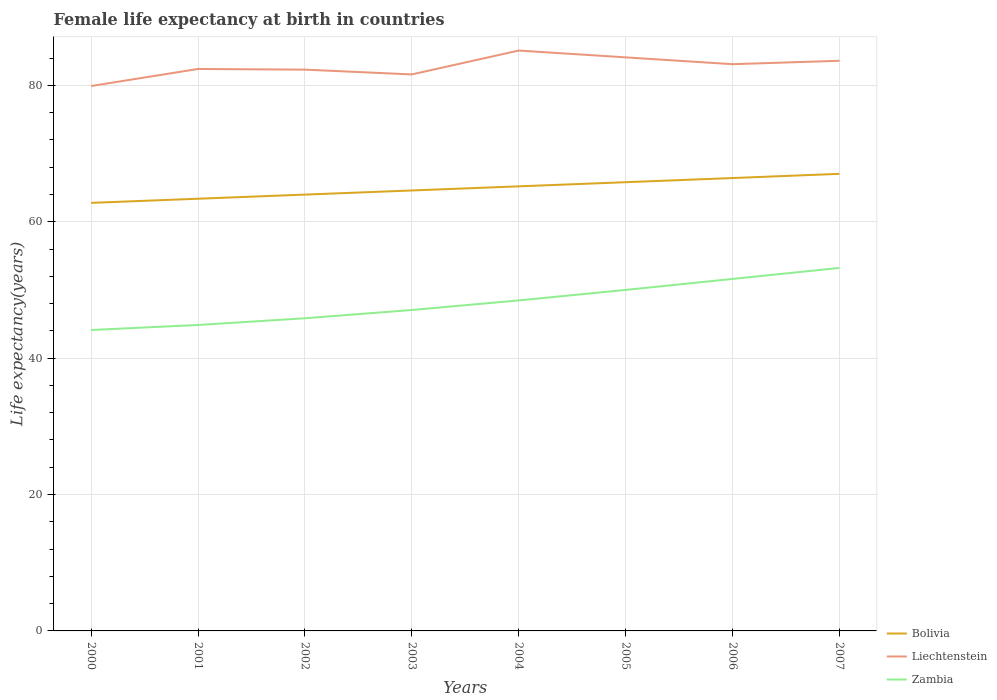How many different coloured lines are there?
Your response must be concise. 3. Across all years, what is the maximum female life expectancy at birth in Bolivia?
Your answer should be very brief. 62.77. What is the total female life expectancy at birth in Zambia in the graph?
Provide a short and direct response. -2.2. What is the difference between the highest and the second highest female life expectancy at birth in Zambia?
Make the answer very short. 9.11. How many lines are there?
Your answer should be compact. 3. Does the graph contain any zero values?
Offer a very short reply. No. Does the graph contain grids?
Provide a short and direct response. Yes. Where does the legend appear in the graph?
Ensure brevity in your answer.  Bottom right. What is the title of the graph?
Provide a short and direct response. Female life expectancy at birth in countries. Does "Yemen, Rep." appear as one of the legend labels in the graph?
Your answer should be very brief. No. What is the label or title of the X-axis?
Make the answer very short. Years. What is the label or title of the Y-axis?
Offer a terse response. Life expectancy(years). What is the Life expectancy(years) of Bolivia in 2000?
Provide a short and direct response. 62.77. What is the Life expectancy(years) of Liechtenstein in 2000?
Offer a very short reply. 79.9. What is the Life expectancy(years) of Zambia in 2000?
Make the answer very short. 44.12. What is the Life expectancy(years) in Bolivia in 2001?
Your answer should be compact. 63.37. What is the Life expectancy(years) in Liechtenstein in 2001?
Your answer should be very brief. 82.4. What is the Life expectancy(years) of Zambia in 2001?
Offer a very short reply. 44.86. What is the Life expectancy(years) in Bolivia in 2002?
Your answer should be compact. 63.98. What is the Life expectancy(years) of Liechtenstein in 2002?
Your response must be concise. 82.3. What is the Life expectancy(years) of Zambia in 2002?
Provide a short and direct response. 45.85. What is the Life expectancy(years) in Bolivia in 2003?
Provide a short and direct response. 64.58. What is the Life expectancy(years) in Liechtenstein in 2003?
Give a very brief answer. 81.6. What is the Life expectancy(years) of Zambia in 2003?
Your answer should be compact. 47.06. What is the Life expectancy(years) of Bolivia in 2004?
Make the answer very short. 65.19. What is the Life expectancy(years) of Liechtenstein in 2004?
Ensure brevity in your answer.  85.1. What is the Life expectancy(years) in Zambia in 2004?
Offer a terse response. 48.46. What is the Life expectancy(years) of Bolivia in 2005?
Your response must be concise. 65.8. What is the Life expectancy(years) of Liechtenstein in 2005?
Give a very brief answer. 84.1. What is the Life expectancy(years) of Zambia in 2005?
Offer a terse response. 50. What is the Life expectancy(years) of Bolivia in 2006?
Offer a terse response. 66.41. What is the Life expectancy(years) of Liechtenstein in 2006?
Provide a short and direct response. 83.1. What is the Life expectancy(years) in Zambia in 2006?
Offer a very short reply. 51.61. What is the Life expectancy(years) of Bolivia in 2007?
Make the answer very short. 67.02. What is the Life expectancy(years) in Liechtenstein in 2007?
Your response must be concise. 83.6. What is the Life expectancy(years) of Zambia in 2007?
Ensure brevity in your answer.  53.23. Across all years, what is the maximum Life expectancy(years) of Bolivia?
Keep it short and to the point. 67.02. Across all years, what is the maximum Life expectancy(years) of Liechtenstein?
Ensure brevity in your answer.  85.1. Across all years, what is the maximum Life expectancy(years) of Zambia?
Keep it short and to the point. 53.23. Across all years, what is the minimum Life expectancy(years) in Bolivia?
Your answer should be very brief. 62.77. Across all years, what is the minimum Life expectancy(years) of Liechtenstein?
Provide a succinct answer. 79.9. Across all years, what is the minimum Life expectancy(years) of Zambia?
Your response must be concise. 44.12. What is the total Life expectancy(years) of Bolivia in the graph?
Ensure brevity in your answer.  519.11. What is the total Life expectancy(years) of Liechtenstein in the graph?
Your response must be concise. 662.1. What is the total Life expectancy(years) of Zambia in the graph?
Your answer should be very brief. 385.19. What is the difference between the Life expectancy(years) of Bolivia in 2000 and that in 2001?
Your answer should be very brief. -0.6. What is the difference between the Life expectancy(years) of Zambia in 2000 and that in 2001?
Offer a very short reply. -0.74. What is the difference between the Life expectancy(years) of Bolivia in 2000 and that in 2002?
Offer a terse response. -1.21. What is the difference between the Life expectancy(years) of Zambia in 2000 and that in 2002?
Keep it short and to the point. -1.73. What is the difference between the Life expectancy(years) in Bolivia in 2000 and that in 2003?
Provide a short and direct response. -1.82. What is the difference between the Life expectancy(years) of Zambia in 2000 and that in 2003?
Your response must be concise. -2.94. What is the difference between the Life expectancy(years) of Bolivia in 2000 and that in 2004?
Give a very brief answer. -2.42. What is the difference between the Life expectancy(years) of Liechtenstein in 2000 and that in 2004?
Your response must be concise. -5.2. What is the difference between the Life expectancy(years) of Zambia in 2000 and that in 2004?
Offer a very short reply. -4.34. What is the difference between the Life expectancy(years) in Bolivia in 2000 and that in 2005?
Make the answer very short. -3.03. What is the difference between the Life expectancy(years) in Liechtenstein in 2000 and that in 2005?
Give a very brief answer. -4.2. What is the difference between the Life expectancy(years) in Zambia in 2000 and that in 2005?
Offer a terse response. -5.88. What is the difference between the Life expectancy(years) of Bolivia in 2000 and that in 2006?
Offer a terse response. -3.64. What is the difference between the Life expectancy(years) of Liechtenstein in 2000 and that in 2006?
Keep it short and to the point. -3.2. What is the difference between the Life expectancy(years) in Zambia in 2000 and that in 2006?
Make the answer very short. -7.49. What is the difference between the Life expectancy(years) of Bolivia in 2000 and that in 2007?
Ensure brevity in your answer.  -4.25. What is the difference between the Life expectancy(years) of Zambia in 2000 and that in 2007?
Offer a terse response. -9.11. What is the difference between the Life expectancy(years) of Bolivia in 2001 and that in 2002?
Provide a succinct answer. -0.61. What is the difference between the Life expectancy(years) in Liechtenstein in 2001 and that in 2002?
Offer a very short reply. 0.1. What is the difference between the Life expectancy(years) in Zambia in 2001 and that in 2002?
Give a very brief answer. -0.98. What is the difference between the Life expectancy(years) of Bolivia in 2001 and that in 2003?
Give a very brief answer. -1.21. What is the difference between the Life expectancy(years) of Liechtenstein in 2001 and that in 2003?
Provide a succinct answer. 0.8. What is the difference between the Life expectancy(years) of Zambia in 2001 and that in 2003?
Your answer should be very brief. -2.2. What is the difference between the Life expectancy(years) of Bolivia in 2001 and that in 2004?
Offer a very short reply. -1.82. What is the difference between the Life expectancy(years) in Liechtenstein in 2001 and that in 2004?
Your answer should be very brief. -2.7. What is the difference between the Life expectancy(years) of Zambia in 2001 and that in 2004?
Ensure brevity in your answer.  -3.6. What is the difference between the Life expectancy(years) in Bolivia in 2001 and that in 2005?
Make the answer very short. -2.42. What is the difference between the Life expectancy(years) of Liechtenstein in 2001 and that in 2005?
Keep it short and to the point. -1.7. What is the difference between the Life expectancy(years) in Zambia in 2001 and that in 2005?
Make the answer very short. -5.14. What is the difference between the Life expectancy(years) in Bolivia in 2001 and that in 2006?
Provide a succinct answer. -3.03. What is the difference between the Life expectancy(years) in Zambia in 2001 and that in 2006?
Your answer should be very brief. -6.75. What is the difference between the Life expectancy(years) in Bolivia in 2001 and that in 2007?
Give a very brief answer. -3.65. What is the difference between the Life expectancy(years) of Liechtenstein in 2001 and that in 2007?
Provide a succinct answer. -1.2. What is the difference between the Life expectancy(years) in Zambia in 2001 and that in 2007?
Provide a short and direct response. -8.37. What is the difference between the Life expectancy(years) in Bolivia in 2002 and that in 2003?
Make the answer very short. -0.61. What is the difference between the Life expectancy(years) of Liechtenstein in 2002 and that in 2003?
Ensure brevity in your answer.  0.7. What is the difference between the Life expectancy(years) of Zambia in 2002 and that in 2003?
Give a very brief answer. -1.21. What is the difference between the Life expectancy(years) of Bolivia in 2002 and that in 2004?
Your answer should be very brief. -1.21. What is the difference between the Life expectancy(years) in Liechtenstein in 2002 and that in 2004?
Keep it short and to the point. -2.8. What is the difference between the Life expectancy(years) of Zambia in 2002 and that in 2004?
Ensure brevity in your answer.  -2.62. What is the difference between the Life expectancy(years) of Bolivia in 2002 and that in 2005?
Offer a terse response. -1.82. What is the difference between the Life expectancy(years) in Liechtenstein in 2002 and that in 2005?
Keep it short and to the point. -1.8. What is the difference between the Life expectancy(years) in Zambia in 2002 and that in 2005?
Your answer should be compact. -4.16. What is the difference between the Life expectancy(years) of Bolivia in 2002 and that in 2006?
Your response must be concise. -2.43. What is the difference between the Life expectancy(years) in Zambia in 2002 and that in 2006?
Keep it short and to the point. -5.77. What is the difference between the Life expectancy(years) in Bolivia in 2002 and that in 2007?
Your response must be concise. -3.04. What is the difference between the Life expectancy(years) in Liechtenstein in 2002 and that in 2007?
Provide a succinct answer. -1.3. What is the difference between the Life expectancy(years) of Zambia in 2002 and that in 2007?
Offer a terse response. -7.38. What is the difference between the Life expectancy(years) in Bolivia in 2003 and that in 2004?
Provide a succinct answer. -0.6. What is the difference between the Life expectancy(years) of Zambia in 2003 and that in 2004?
Make the answer very short. -1.4. What is the difference between the Life expectancy(years) in Bolivia in 2003 and that in 2005?
Offer a terse response. -1.21. What is the difference between the Life expectancy(years) in Liechtenstein in 2003 and that in 2005?
Provide a succinct answer. -2.5. What is the difference between the Life expectancy(years) of Zambia in 2003 and that in 2005?
Your answer should be very brief. -2.94. What is the difference between the Life expectancy(years) in Bolivia in 2003 and that in 2006?
Your answer should be very brief. -1.82. What is the difference between the Life expectancy(years) in Liechtenstein in 2003 and that in 2006?
Make the answer very short. -1.5. What is the difference between the Life expectancy(years) in Zambia in 2003 and that in 2006?
Give a very brief answer. -4.55. What is the difference between the Life expectancy(years) of Bolivia in 2003 and that in 2007?
Provide a succinct answer. -2.44. What is the difference between the Life expectancy(years) of Liechtenstein in 2003 and that in 2007?
Offer a very short reply. -2. What is the difference between the Life expectancy(years) in Zambia in 2003 and that in 2007?
Make the answer very short. -6.17. What is the difference between the Life expectancy(years) in Bolivia in 2004 and that in 2005?
Give a very brief answer. -0.61. What is the difference between the Life expectancy(years) in Liechtenstein in 2004 and that in 2005?
Your answer should be compact. 1. What is the difference between the Life expectancy(years) of Zambia in 2004 and that in 2005?
Ensure brevity in your answer.  -1.54. What is the difference between the Life expectancy(years) in Bolivia in 2004 and that in 2006?
Provide a short and direct response. -1.22. What is the difference between the Life expectancy(years) in Zambia in 2004 and that in 2006?
Your response must be concise. -3.15. What is the difference between the Life expectancy(years) in Bolivia in 2004 and that in 2007?
Ensure brevity in your answer.  -1.83. What is the difference between the Life expectancy(years) of Zambia in 2004 and that in 2007?
Offer a terse response. -4.76. What is the difference between the Life expectancy(years) in Bolivia in 2005 and that in 2006?
Make the answer very short. -0.61. What is the difference between the Life expectancy(years) of Zambia in 2005 and that in 2006?
Ensure brevity in your answer.  -1.61. What is the difference between the Life expectancy(years) in Bolivia in 2005 and that in 2007?
Your answer should be very brief. -1.22. What is the difference between the Life expectancy(years) of Zambia in 2005 and that in 2007?
Make the answer very short. -3.23. What is the difference between the Life expectancy(years) in Bolivia in 2006 and that in 2007?
Offer a very short reply. -0.61. What is the difference between the Life expectancy(years) of Zambia in 2006 and that in 2007?
Your response must be concise. -1.61. What is the difference between the Life expectancy(years) of Bolivia in 2000 and the Life expectancy(years) of Liechtenstein in 2001?
Your response must be concise. -19.63. What is the difference between the Life expectancy(years) in Bolivia in 2000 and the Life expectancy(years) in Zambia in 2001?
Keep it short and to the point. 17.91. What is the difference between the Life expectancy(years) in Liechtenstein in 2000 and the Life expectancy(years) in Zambia in 2001?
Give a very brief answer. 35.04. What is the difference between the Life expectancy(years) in Bolivia in 2000 and the Life expectancy(years) in Liechtenstein in 2002?
Your answer should be very brief. -19.53. What is the difference between the Life expectancy(years) of Bolivia in 2000 and the Life expectancy(years) of Zambia in 2002?
Ensure brevity in your answer.  16.92. What is the difference between the Life expectancy(years) in Liechtenstein in 2000 and the Life expectancy(years) in Zambia in 2002?
Keep it short and to the point. 34.05. What is the difference between the Life expectancy(years) in Bolivia in 2000 and the Life expectancy(years) in Liechtenstein in 2003?
Provide a short and direct response. -18.83. What is the difference between the Life expectancy(years) in Bolivia in 2000 and the Life expectancy(years) in Zambia in 2003?
Your answer should be very brief. 15.71. What is the difference between the Life expectancy(years) of Liechtenstein in 2000 and the Life expectancy(years) of Zambia in 2003?
Your answer should be very brief. 32.84. What is the difference between the Life expectancy(years) in Bolivia in 2000 and the Life expectancy(years) in Liechtenstein in 2004?
Provide a short and direct response. -22.33. What is the difference between the Life expectancy(years) of Bolivia in 2000 and the Life expectancy(years) of Zambia in 2004?
Offer a terse response. 14.3. What is the difference between the Life expectancy(years) in Liechtenstein in 2000 and the Life expectancy(years) in Zambia in 2004?
Offer a terse response. 31.44. What is the difference between the Life expectancy(years) in Bolivia in 2000 and the Life expectancy(years) in Liechtenstein in 2005?
Provide a succinct answer. -21.33. What is the difference between the Life expectancy(years) in Bolivia in 2000 and the Life expectancy(years) in Zambia in 2005?
Make the answer very short. 12.77. What is the difference between the Life expectancy(years) in Liechtenstein in 2000 and the Life expectancy(years) in Zambia in 2005?
Offer a terse response. 29.9. What is the difference between the Life expectancy(years) of Bolivia in 2000 and the Life expectancy(years) of Liechtenstein in 2006?
Make the answer very short. -20.33. What is the difference between the Life expectancy(years) in Bolivia in 2000 and the Life expectancy(years) in Zambia in 2006?
Provide a short and direct response. 11.15. What is the difference between the Life expectancy(years) in Liechtenstein in 2000 and the Life expectancy(years) in Zambia in 2006?
Offer a terse response. 28.29. What is the difference between the Life expectancy(years) in Bolivia in 2000 and the Life expectancy(years) in Liechtenstein in 2007?
Your answer should be compact. -20.83. What is the difference between the Life expectancy(years) of Bolivia in 2000 and the Life expectancy(years) of Zambia in 2007?
Your answer should be compact. 9.54. What is the difference between the Life expectancy(years) in Liechtenstein in 2000 and the Life expectancy(years) in Zambia in 2007?
Make the answer very short. 26.67. What is the difference between the Life expectancy(years) in Bolivia in 2001 and the Life expectancy(years) in Liechtenstein in 2002?
Give a very brief answer. -18.93. What is the difference between the Life expectancy(years) in Bolivia in 2001 and the Life expectancy(years) in Zambia in 2002?
Provide a succinct answer. 17.53. What is the difference between the Life expectancy(years) of Liechtenstein in 2001 and the Life expectancy(years) of Zambia in 2002?
Offer a terse response. 36.55. What is the difference between the Life expectancy(years) of Bolivia in 2001 and the Life expectancy(years) of Liechtenstein in 2003?
Keep it short and to the point. -18.23. What is the difference between the Life expectancy(years) in Bolivia in 2001 and the Life expectancy(years) in Zambia in 2003?
Your answer should be very brief. 16.31. What is the difference between the Life expectancy(years) of Liechtenstein in 2001 and the Life expectancy(years) of Zambia in 2003?
Your response must be concise. 35.34. What is the difference between the Life expectancy(years) of Bolivia in 2001 and the Life expectancy(years) of Liechtenstein in 2004?
Make the answer very short. -21.73. What is the difference between the Life expectancy(years) in Bolivia in 2001 and the Life expectancy(years) in Zambia in 2004?
Keep it short and to the point. 14.91. What is the difference between the Life expectancy(years) of Liechtenstein in 2001 and the Life expectancy(years) of Zambia in 2004?
Your answer should be compact. 33.94. What is the difference between the Life expectancy(years) in Bolivia in 2001 and the Life expectancy(years) in Liechtenstein in 2005?
Provide a short and direct response. -20.73. What is the difference between the Life expectancy(years) of Bolivia in 2001 and the Life expectancy(years) of Zambia in 2005?
Your response must be concise. 13.37. What is the difference between the Life expectancy(years) in Liechtenstein in 2001 and the Life expectancy(years) in Zambia in 2005?
Offer a terse response. 32.4. What is the difference between the Life expectancy(years) in Bolivia in 2001 and the Life expectancy(years) in Liechtenstein in 2006?
Offer a terse response. -19.73. What is the difference between the Life expectancy(years) of Bolivia in 2001 and the Life expectancy(years) of Zambia in 2006?
Give a very brief answer. 11.76. What is the difference between the Life expectancy(years) of Liechtenstein in 2001 and the Life expectancy(years) of Zambia in 2006?
Keep it short and to the point. 30.79. What is the difference between the Life expectancy(years) of Bolivia in 2001 and the Life expectancy(years) of Liechtenstein in 2007?
Provide a succinct answer. -20.23. What is the difference between the Life expectancy(years) of Bolivia in 2001 and the Life expectancy(years) of Zambia in 2007?
Offer a very short reply. 10.14. What is the difference between the Life expectancy(years) in Liechtenstein in 2001 and the Life expectancy(years) in Zambia in 2007?
Provide a short and direct response. 29.17. What is the difference between the Life expectancy(years) in Bolivia in 2002 and the Life expectancy(years) in Liechtenstein in 2003?
Provide a short and direct response. -17.62. What is the difference between the Life expectancy(years) in Bolivia in 2002 and the Life expectancy(years) in Zambia in 2003?
Provide a short and direct response. 16.92. What is the difference between the Life expectancy(years) in Liechtenstein in 2002 and the Life expectancy(years) in Zambia in 2003?
Your answer should be very brief. 35.24. What is the difference between the Life expectancy(years) in Bolivia in 2002 and the Life expectancy(years) in Liechtenstein in 2004?
Your response must be concise. -21.12. What is the difference between the Life expectancy(years) of Bolivia in 2002 and the Life expectancy(years) of Zambia in 2004?
Your response must be concise. 15.52. What is the difference between the Life expectancy(years) of Liechtenstein in 2002 and the Life expectancy(years) of Zambia in 2004?
Offer a terse response. 33.84. What is the difference between the Life expectancy(years) in Bolivia in 2002 and the Life expectancy(years) in Liechtenstein in 2005?
Ensure brevity in your answer.  -20.12. What is the difference between the Life expectancy(years) in Bolivia in 2002 and the Life expectancy(years) in Zambia in 2005?
Provide a succinct answer. 13.98. What is the difference between the Life expectancy(years) of Liechtenstein in 2002 and the Life expectancy(years) of Zambia in 2005?
Keep it short and to the point. 32.3. What is the difference between the Life expectancy(years) in Bolivia in 2002 and the Life expectancy(years) in Liechtenstein in 2006?
Your response must be concise. -19.12. What is the difference between the Life expectancy(years) of Bolivia in 2002 and the Life expectancy(years) of Zambia in 2006?
Make the answer very short. 12.37. What is the difference between the Life expectancy(years) in Liechtenstein in 2002 and the Life expectancy(years) in Zambia in 2006?
Offer a terse response. 30.69. What is the difference between the Life expectancy(years) of Bolivia in 2002 and the Life expectancy(years) of Liechtenstein in 2007?
Offer a very short reply. -19.62. What is the difference between the Life expectancy(years) of Bolivia in 2002 and the Life expectancy(years) of Zambia in 2007?
Your answer should be very brief. 10.75. What is the difference between the Life expectancy(years) in Liechtenstein in 2002 and the Life expectancy(years) in Zambia in 2007?
Give a very brief answer. 29.07. What is the difference between the Life expectancy(years) of Bolivia in 2003 and the Life expectancy(years) of Liechtenstein in 2004?
Your answer should be very brief. -20.52. What is the difference between the Life expectancy(years) of Bolivia in 2003 and the Life expectancy(years) of Zambia in 2004?
Your response must be concise. 16.12. What is the difference between the Life expectancy(years) of Liechtenstein in 2003 and the Life expectancy(years) of Zambia in 2004?
Offer a terse response. 33.14. What is the difference between the Life expectancy(years) in Bolivia in 2003 and the Life expectancy(years) in Liechtenstein in 2005?
Offer a terse response. -19.52. What is the difference between the Life expectancy(years) of Bolivia in 2003 and the Life expectancy(years) of Zambia in 2005?
Offer a terse response. 14.58. What is the difference between the Life expectancy(years) in Liechtenstein in 2003 and the Life expectancy(years) in Zambia in 2005?
Offer a very short reply. 31.6. What is the difference between the Life expectancy(years) of Bolivia in 2003 and the Life expectancy(years) of Liechtenstein in 2006?
Offer a terse response. -18.52. What is the difference between the Life expectancy(years) of Bolivia in 2003 and the Life expectancy(years) of Zambia in 2006?
Your answer should be compact. 12.97. What is the difference between the Life expectancy(years) in Liechtenstein in 2003 and the Life expectancy(years) in Zambia in 2006?
Provide a succinct answer. 29.99. What is the difference between the Life expectancy(years) of Bolivia in 2003 and the Life expectancy(years) of Liechtenstein in 2007?
Your answer should be compact. -19.02. What is the difference between the Life expectancy(years) in Bolivia in 2003 and the Life expectancy(years) in Zambia in 2007?
Offer a very short reply. 11.36. What is the difference between the Life expectancy(years) of Liechtenstein in 2003 and the Life expectancy(years) of Zambia in 2007?
Ensure brevity in your answer.  28.37. What is the difference between the Life expectancy(years) in Bolivia in 2004 and the Life expectancy(years) in Liechtenstein in 2005?
Provide a short and direct response. -18.91. What is the difference between the Life expectancy(years) in Bolivia in 2004 and the Life expectancy(years) in Zambia in 2005?
Provide a short and direct response. 15.19. What is the difference between the Life expectancy(years) in Liechtenstein in 2004 and the Life expectancy(years) in Zambia in 2005?
Offer a terse response. 35.1. What is the difference between the Life expectancy(years) of Bolivia in 2004 and the Life expectancy(years) of Liechtenstein in 2006?
Offer a very short reply. -17.91. What is the difference between the Life expectancy(years) of Bolivia in 2004 and the Life expectancy(years) of Zambia in 2006?
Keep it short and to the point. 13.58. What is the difference between the Life expectancy(years) in Liechtenstein in 2004 and the Life expectancy(years) in Zambia in 2006?
Provide a succinct answer. 33.49. What is the difference between the Life expectancy(years) in Bolivia in 2004 and the Life expectancy(years) in Liechtenstein in 2007?
Offer a terse response. -18.41. What is the difference between the Life expectancy(years) of Bolivia in 2004 and the Life expectancy(years) of Zambia in 2007?
Ensure brevity in your answer.  11.96. What is the difference between the Life expectancy(years) in Liechtenstein in 2004 and the Life expectancy(years) in Zambia in 2007?
Provide a short and direct response. 31.87. What is the difference between the Life expectancy(years) in Bolivia in 2005 and the Life expectancy(years) in Liechtenstein in 2006?
Your answer should be very brief. -17.3. What is the difference between the Life expectancy(years) in Bolivia in 2005 and the Life expectancy(years) in Zambia in 2006?
Provide a short and direct response. 14.18. What is the difference between the Life expectancy(years) in Liechtenstein in 2005 and the Life expectancy(years) in Zambia in 2006?
Your answer should be very brief. 32.49. What is the difference between the Life expectancy(years) in Bolivia in 2005 and the Life expectancy(years) in Liechtenstein in 2007?
Give a very brief answer. -17.8. What is the difference between the Life expectancy(years) in Bolivia in 2005 and the Life expectancy(years) in Zambia in 2007?
Ensure brevity in your answer.  12.57. What is the difference between the Life expectancy(years) of Liechtenstein in 2005 and the Life expectancy(years) of Zambia in 2007?
Your answer should be very brief. 30.87. What is the difference between the Life expectancy(years) in Bolivia in 2006 and the Life expectancy(years) in Liechtenstein in 2007?
Your response must be concise. -17.19. What is the difference between the Life expectancy(years) in Bolivia in 2006 and the Life expectancy(years) in Zambia in 2007?
Provide a succinct answer. 13.18. What is the difference between the Life expectancy(years) in Liechtenstein in 2006 and the Life expectancy(years) in Zambia in 2007?
Provide a succinct answer. 29.87. What is the average Life expectancy(years) of Bolivia per year?
Offer a very short reply. 64.89. What is the average Life expectancy(years) in Liechtenstein per year?
Keep it short and to the point. 82.76. What is the average Life expectancy(years) in Zambia per year?
Your answer should be compact. 48.15. In the year 2000, what is the difference between the Life expectancy(years) in Bolivia and Life expectancy(years) in Liechtenstein?
Provide a short and direct response. -17.13. In the year 2000, what is the difference between the Life expectancy(years) of Bolivia and Life expectancy(years) of Zambia?
Give a very brief answer. 18.65. In the year 2000, what is the difference between the Life expectancy(years) of Liechtenstein and Life expectancy(years) of Zambia?
Your answer should be very brief. 35.78. In the year 2001, what is the difference between the Life expectancy(years) in Bolivia and Life expectancy(years) in Liechtenstein?
Your response must be concise. -19.03. In the year 2001, what is the difference between the Life expectancy(years) in Bolivia and Life expectancy(years) in Zambia?
Make the answer very short. 18.51. In the year 2001, what is the difference between the Life expectancy(years) of Liechtenstein and Life expectancy(years) of Zambia?
Provide a succinct answer. 37.54. In the year 2002, what is the difference between the Life expectancy(years) of Bolivia and Life expectancy(years) of Liechtenstein?
Offer a terse response. -18.32. In the year 2002, what is the difference between the Life expectancy(years) of Bolivia and Life expectancy(years) of Zambia?
Your response must be concise. 18.13. In the year 2002, what is the difference between the Life expectancy(years) in Liechtenstein and Life expectancy(years) in Zambia?
Provide a short and direct response. 36.45. In the year 2003, what is the difference between the Life expectancy(years) in Bolivia and Life expectancy(years) in Liechtenstein?
Provide a short and direct response. -17.02. In the year 2003, what is the difference between the Life expectancy(years) of Bolivia and Life expectancy(years) of Zambia?
Offer a very short reply. 17.53. In the year 2003, what is the difference between the Life expectancy(years) of Liechtenstein and Life expectancy(years) of Zambia?
Keep it short and to the point. 34.54. In the year 2004, what is the difference between the Life expectancy(years) in Bolivia and Life expectancy(years) in Liechtenstein?
Offer a very short reply. -19.91. In the year 2004, what is the difference between the Life expectancy(years) of Bolivia and Life expectancy(years) of Zambia?
Offer a very short reply. 16.73. In the year 2004, what is the difference between the Life expectancy(years) of Liechtenstein and Life expectancy(years) of Zambia?
Keep it short and to the point. 36.64. In the year 2005, what is the difference between the Life expectancy(years) of Bolivia and Life expectancy(years) of Liechtenstein?
Provide a succinct answer. -18.3. In the year 2005, what is the difference between the Life expectancy(years) in Bolivia and Life expectancy(years) in Zambia?
Your answer should be compact. 15.79. In the year 2005, what is the difference between the Life expectancy(years) of Liechtenstein and Life expectancy(years) of Zambia?
Keep it short and to the point. 34.1. In the year 2006, what is the difference between the Life expectancy(years) in Bolivia and Life expectancy(years) in Liechtenstein?
Provide a short and direct response. -16.69. In the year 2006, what is the difference between the Life expectancy(years) in Bolivia and Life expectancy(years) in Zambia?
Make the answer very short. 14.79. In the year 2006, what is the difference between the Life expectancy(years) of Liechtenstein and Life expectancy(years) of Zambia?
Make the answer very short. 31.49. In the year 2007, what is the difference between the Life expectancy(years) in Bolivia and Life expectancy(years) in Liechtenstein?
Your response must be concise. -16.58. In the year 2007, what is the difference between the Life expectancy(years) of Bolivia and Life expectancy(years) of Zambia?
Your response must be concise. 13.79. In the year 2007, what is the difference between the Life expectancy(years) of Liechtenstein and Life expectancy(years) of Zambia?
Your answer should be compact. 30.37. What is the ratio of the Life expectancy(years) of Bolivia in 2000 to that in 2001?
Offer a very short reply. 0.99. What is the ratio of the Life expectancy(years) in Liechtenstein in 2000 to that in 2001?
Your response must be concise. 0.97. What is the ratio of the Life expectancy(years) in Zambia in 2000 to that in 2001?
Offer a terse response. 0.98. What is the ratio of the Life expectancy(years) in Bolivia in 2000 to that in 2002?
Give a very brief answer. 0.98. What is the ratio of the Life expectancy(years) of Liechtenstein in 2000 to that in 2002?
Keep it short and to the point. 0.97. What is the ratio of the Life expectancy(years) of Zambia in 2000 to that in 2002?
Provide a succinct answer. 0.96. What is the ratio of the Life expectancy(years) of Bolivia in 2000 to that in 2003?
Ensure brevity in your answer.  0.97. What is the ratio of the Life expectancy(years) in Liechtenstein in 2000 to that in 2003?
Your answer should be very brief. 0.98. What is the ratio of the Life expectancy(years) of Zambia in 2000 to that in 2003?
Ensure brevity in your answer.  0.94. What is the ratio of the Life expectancy(years) of Bolivia in 2000 to that in 2004?
Your response must be concise. 0.96. What is the ratio of the Life expectancy(years) of Liechtenstein in 2000 to that in 2004?
Make the answer very short. 0.94. What is the ratio of the Life expectancy(years) in Zambia in 2000 to that in 2004?
Keep it short and to the point. 0.91. What is the ratio of the Life expectancy(years) of Bolivia in 2000 to that in 2005?
Provide a succinct answer. 0.95. What is the ratio of the Life expectancy(years) in Liechtenstein in 2000 to that in 2005?
Offer a terse response. 0.95. What is the ratio of the Life expectancy(years) of Zambia in 2000 to that in 2005?
Make the answer very short. 0.88. What is the ratio of the Life expectancy(years) in Bolivia in 2000 to that in 2006?
Offer a very short reply. 0.95. What is the ratio of the Life expectancy(years) of Liechtenstein in 2000 to that in 2006?
Make the answer very short. 0.96. What is the ratio of the Life expectancy(years) in Zambia in 2000 to that in 2006?
Give a very brief answer. 0.85. What is the ratio of the Life expectancy(years) of Bolivia in 2000 to that in 2007?
Give a very brief answer. 0.94. What is the ratio of the Life expectancy(years) in Liechtenstein in 2000 to that in 2007?
Make the answer very short. 0.96. What is the ratio of the Life expectancy(years) of Zambia in 2000 to that in 2007?
Offer a terse response. 0.83. What is the ratio of the Life expectancy(years) of Liechtenstein in 2001 to that in 2002?
Provide a short and direct response. 1. What is the ratio of the Life expectancy(years) of Zambia in 2001 to that in 2002?
Keep it short and to the point. 0.98. What is the ratio of the Life expectancy(years) in Bolivia in 2001 to that in 2003?
Ensure brevity in your answer.  0.98. What is the ratio of the Life expectancy(years) in Liechtenstein in 2001 to that in 2003?
Offer a very short reply. 1.01. What is the ratio of the Life expectancy(years) in Zambia in 2001 to that in 2003?
Your answer should be compact. 0.95. What is the ratio of the Life expectancy(years) in Bolivia in 2001 to that in 2004?
Provide a short and direct response. 0.97. What is the ratio of the Life expectancy(years) in Liechtenstein in 2001 to that in 2004?
Provide a succinct answer. 0.97. What is the ratio of the Life expectancy(years) of Zambia in 2001 to that in 2004?
Keep it short and to the point. 0.93. What is the ratio of the Life expectancy(years) of Bolivia in 2001 to that in 2005?
Your answer should be compact. 0.96. What is the ratio of the Life expectancy(years) of Liechtenstein in 2001 to that in 2005?
Ensure brevity in your answer.  0.98. What is the ratio of the Life expectancy(years) in Zambia in 2001 to that in 2005?
Offer a very short reply. 0.9. What is the ratio of the Life expectancy(years) of Bolivia in 2001 to that in 2006?
Offer a terse response. 0.95. What is the ratio of the Life expectancy(years) in Liechtenstein in 2001 to that in 2006?
Your answer should be compact. 0.99. What is the ratio of the Life expectancy(years) in Zambia in 2001 to that in 2006?
Provide a short and direct response. 0.87. What is the ratio of the Life expectancy(years) of Bolivia in 2001 to that in 2007?
Your answer should be very brief. 0.95. What is the ratio of the Life expectancy(years) in Liechtenstein in 2001 to that in 2007?
Your response must be concise. 0.99. What is the ratio of the Life expectancy(years) in Zambia in 2001 to that in 2007?
Provide a short and direct response. 0.84. What is the ratio of the Life expectancy(years) of Bolivia in 2002 to that in 2003?
Keep it short and to the point. 0.99. What is the ratio of the Life expectancy(years) of Liechtenstein in 2002 to that in 2003?
Provide a short and direct response. 1.01. What is the ratio of the Life expectancy(years) of Zambia in 2002 to that in 2003?
Ensure brevity in your answer.  0.97. What is the ratio of the Life expectancy(years) in Bolivia in 2002 to that in 2004?
Your response must be concise. 0.98. What is the ratio of the Life expectancy(years) of Liechtenstein in 2002 to that in 2004?
Your answer should be compact. 0.97. What is the ratio of the Life expectancy(years) of Zambia in 2002 to that in 2004?
Your answer should be very brief. 0.95. What is the ratio of the Life expectancy(years) of Bolivia in 2002 to that in 2005?
Offer a terse response. 0.97. What is the ratio of the Life expectancy(years) in Liechtenstein in 2002 to that in 2005?
Ensure brevity in your answer.  0.98. What is the ratio of the Life expectancy(years) of Zambia in 2002 to that in 2005?
Make the answer very short. 0.92. What is the ratio of the Life expectancy(years) of Bolivia in 2002 to that in 2006?
Your answer should be very brief. 0.96. What is the ratio of the Life expectancy(years) in Liechtenstein in 2002 to that in 2006?
Provide a succinct answer. 0.99. What is the ratio of the Life expectancy(years) in Zambia in 2002 to that in 2006?
Your response must be concise. 0.89. What is the ratio of the Life expectancy(years) of Bolivia in 2002 to that in 2007?
Your answer should be compact. 0.95. What is the ratio of the Life expectancy(years) in Liechtenstein in 2002 to that in 2007?
Provide a succinct answer. 0.98. What is the ratio of the Life expectancy(years) in Zambia in 2002 to that in 2007?
Make the answer very short. 0.86. What is the ratio of the Life expectancy(years) of Liechtenstein in 2003 to that in 2004?
Provide a short and direct response. 0.96. What is the ratio of the Life expectancy(years) of Zambia in 2003 to that in 2004?
Ensure brevity in your answer.  0.97. What is the ratio of the Life expectancy(years) of Bolivia in 2003 to that in 2005?
Keep it short and to the point. 0.98. What is the ratio of the Life expectancy(years) in Liechtenstein in 2003 to that in 2005?
Your answer should be very brief. 0.97. What is the ratio of the Life expectancy(years) of Zambia in 2003 to that in 2005?
Give a very brief answer. 0.94. What is the ratio of the Life expectancy(years) in Bolivia in 2003 to that in 2006?
Offer a very short reply. 0.97. What is the ratio of the Life expectancy(years) in Liechtenstein in 2003 to that in 2006?
Give a very brief answer. 0.98. What is the ratio of the Life expectancy(years) in Zambia in 2003 to that in 2006?
Give a very brief answer. 0.91. What is the ratio of the Life expectancy(years) in Bolivia in 2003 to that in 2007?
Make the answer very short. 0.96. What is the ratio of the Life expectancy(years) of Liechtenstein in 2003 to that in 2007?
Ensure brevity in your answer.  0.98. What is the ratio of the Life expectancy(years) in Zambia in 2003 to that in 2007?
Give a very brief answer. 0.88. What is the ratio of the Life expectancy(years) in Liechtenstein in 2004 to that in 2005?
Give a very brief answer. 1.01. What is the ratio of the Life expectancy(years) in Zambia in 2004 to that in 2005?
Your answer should be compact. 0.97. What is the ratio of the Life expectancy(years) of Bolivia in 2004 to that in 2006?
Your answer should be very brief. 0.98. What is the ratio of the Life expectancy(years) of Liechtenstein in 2004 to that in 2006?
Keep it short and to the point. 1.02. What is the ratio of the Life expectancy(years) of Zambia in 2004 to that in 2006?
Provide a short and direct response. 0.94. What is the ratio of the Life expectancy(years) of Bolivia in 2004 to that in 2007?
Provide a short and direct response. 0.97. What is the ratio of the Life expectancy(years) in Liechtenstein in 2004 to that in 2007?
Your answer should be compact. 1.02. What is the ratio of the Life expectancy(years) of Zambia in 2004 to that in 2007?
Provide a succinct answer. 0.91. What is the ratio of the Life expectancy(years) of Liechtenstein in 2005 to that in 2006?
Offer a terse response. 1.01. What is the ratio of the Life expectancy(years) of Zambia in 2005 to that in 2006?
Offer a very short reply. 0.97. What is the ratio of the Life expectancy(years) in Bolivia in 2005 to that in 2007?
Give a very brief answer. 0.98. What is the ratio of the Life expectancy(years) in Zambia in 2005 to that in 2007?
Provide a short and direct response. 0.94. What is the ratio of the Life expectancy(years) in Bolivia in 2006 to that in 2007?
Keep it short and to the point. 0.99. What is the ratio of the Life expectancy(years) of Liechtenstein in 2006 to that in 2007?
Provide a succinct answer. 0.99. What is the ratio of the Life expectancy(years) in Zambia in 2006 to that in 2007?
Ensure brevity in your answer.  0.97. What is the difference between the highest and the second highest Life expectancy(years) in Bolivia?
Your answer should be compact. 0.61. What is the difference between the highest and the second highest Life expectancy(years) of Liechtenstein?
Your response must be concise. 1. What is the difference between the highest and the second highest Life expectancy(years) in Zambia?
Your answer should be compact. 1.61. What is the difference between the highest and the lowest Life expectancy(years) of Bolivia?
Ensure brevity in your answer.  4.25. What is the difference between the highest and the lowest Life expectancy(years) of Liechtenstein?
Keep it short and to the point. 5.2. What is the difference between the highest and the lowest Life expectancy(years) in Zambia?
Your answer should be very brief. 9.11. 